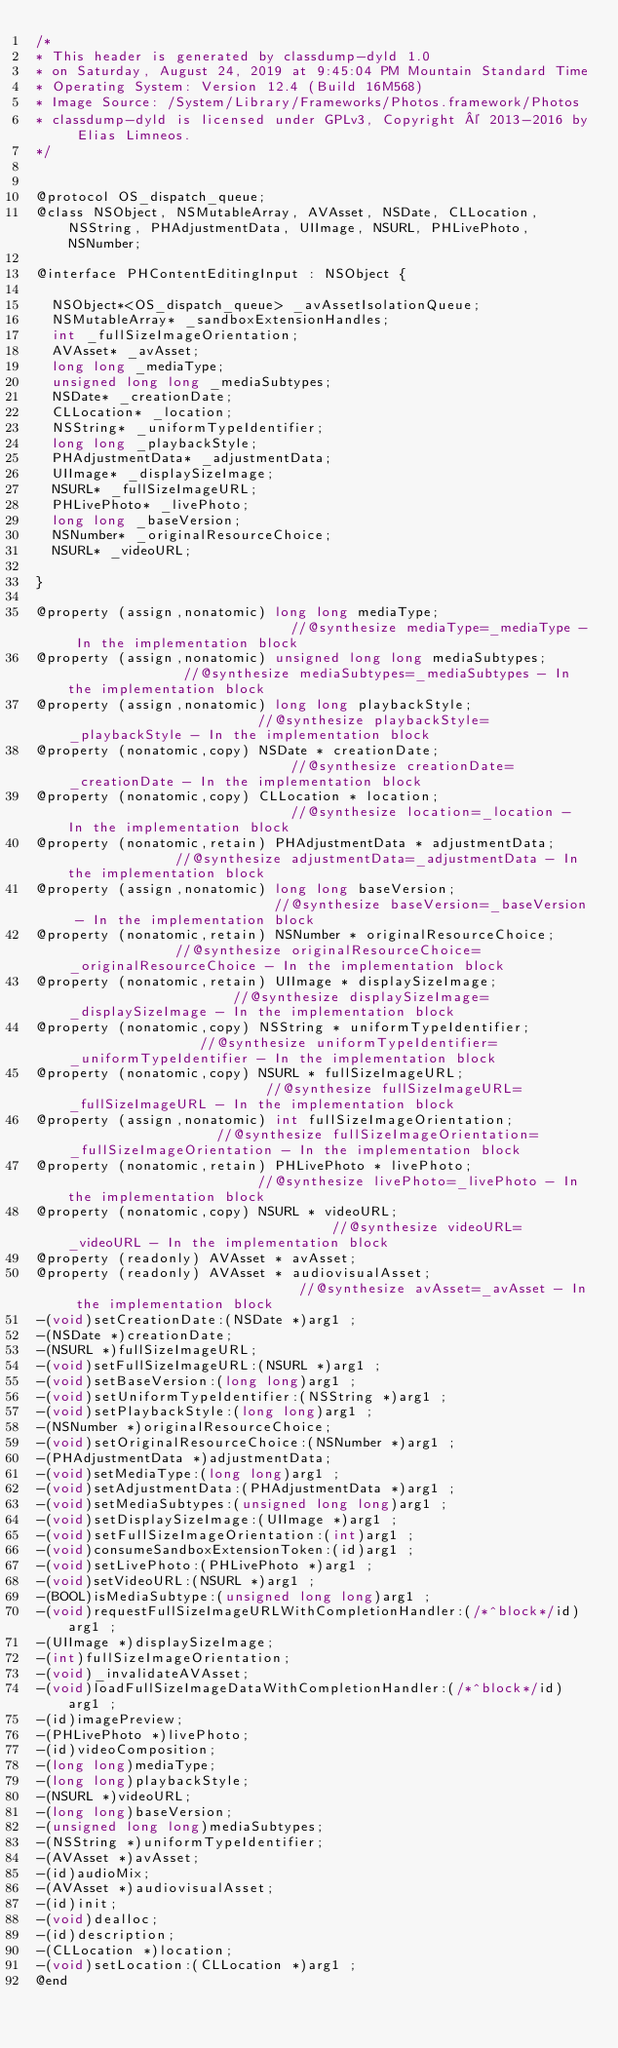Convert code to text. <code><loc_0><loc_0><loc_500><loc_500><_C_>/*
* This header is generated by classdump-dyld 1.0
* on Saturday, August 24, 2019 at 9:45:04 PM Mountain Standard Time
* Operating System: Version 12.4 (Build 16M568)
* Image Source: /System/Library/Frameworks/Photos.framework/Photos
* classdump-dyld is licensed under GPLv3, Copyright © 2013-2016 by Elias Limneos.
*/


@protocol OS_dispatch_queue;
@class NSObject, NSMutableArray, AVAsset, NSDate, CLLocation, NSString, PHAdjustmentData, UIImage, NSURL, PHLivePhoto, NSNumber;

@interface PHContentEditingInput : NSObject {

	NSObject*<OS_dispatch_queue> _avAssetIsolationQueue;
	NSMutableArray* _sandboxExtensionHandles;
	int _fullSizeImageOrientation;
	AVAsset* _avAsset;
	long long _mediaType;
	unsigned long long _mediaSubtypes;
	NSDate* _creationDate;
	CLLocation* _location;
	NSString* _uniformTypeIdentifier;
	long long _playbackStyle;
	PHAdjustmentData* _adjustmentData;
	UIImage* _displaySizeImage;
	NSURL* _fullSizeImageURL;
	PHLivePhoto* _livePhoto;
	long long _baseVersion;
	NSNumber* _originalResourceChoice;
	NSURL* _videoURL;

}

@property (assign,nonatomic) long long mediaType;                            //@synthesize mediaType=_mediaType - In the implementation block
@property (assign,nonatomic) unsigned long long mediaSubtypes;               //@synthesize mediaSubtypes=_mediaSubtypes - In the implementation block
@property (assign,nonatomic) long long playbackStyle;                        //@synthesize playbackStyle=_playbackStyle - In the implementation block
@property (nonatomic,copy) NSDate * creationDate;                            //@synthesize creationDate=_creationDate - In the implementation block
@property (nonatomic,copy) CLLocation * location;                            //@synthesize location=_location - In the implementation block
@property (nonatomic,retain) PHAdjustmentData * adjustmentData;              //@synthesize adjustmentData=_adjustmentData - In the implementation block
@property (assign,nonatomic) long long baseVersion;                          //@synthesize baseVersion=_baseVersion - In the implementation block
@property (nonatomic,retain) NSNumber * originalResourceChoice;              //@synthesize originalResourceChoice=_originalResourceChoice - In the implementation block
@property (nonatomic,retain) UIImage * displaySizeImage;                     //@synthesize displaySizeImage=_displaySizeImage - In the implementation block
@property (nonatomic,copy) NSString * uniformTypeIdentifier;                 //@synthesize uniformTypeIdentifier=_uniformTypeIdentifier - In the implementation block
@property (nonatomic,copy) NSURL * fullSizeImageURL;                         //@synthesize fullSizeImageURL=_fullSizeImageURL - In the implementation block
@property (assign,nonatomic) int fullSizeImageOrientation;                   //@synthesize fullSizeImageOrientation=_fullSizeImageOrientation - In the implementation block
@property (nonatomic,retain) PHLivePhoto * livePhoto;                        //@synthesize livePhoto=_livePhoto - In the implementation block
@property (nonatomic,copy) NSURL * videoURL;                                 //@synthesize videoURL=_videoURL - In the implementation block
@property (readonly) AVAsset * avAsset; 
@property (readonly) AVAsset * audiovisualAsset;                             //@synthesize avAsset=_avAsset - In the implementation block
-(void)setCreationDate:(NSDate *)arg1 ;
-(NSDate *)creationDate;
-(NSURL *)fullSizeImageURL;
-(void)setFullSizeImageURL:(NSURL *)arg1 ;
-(void)setBaseVersion:(long long)arg1 ;
-(void)setUniformTypeIdentifier:(NSString *)arg1 ;
-(void)setPlaybackStyle:(long long)arg1 ;
-(NSNumber *)originalResourceChoice;
-(void)setOriginalResourceChoice:(NSNumber *)arg1 ;
-(PHAdjustmentData *)adjustmentData;
-(void)setMediaType:(long long)arg1 ;
-(void)setAdjustmentData:(PHAdjustmentData *)arg1 ;
-(void)setMediaSubtypes:(unsigned long long)arg1 ;
-(void)setDisplaySizeImage:(UIImage *)arg1 ;
-(void)setFullSizeImageOrientation:(int)arg1 ;
-(void)consumeSandboxExtensionToken:(id)arg1 ;
-(void)setLivePhoto:(PHLivePhoto *)arg1 ;
-(void)setVideoURL:(NSURL *)arg1 ;
-(BOOL)isMediaSubtype:(unsigned long long)arg1 ;
-(void)requestFullSizeImageURLWithCompletionHandler:(/*^block*/id)arg1 ;
-(UIImage *)displaySizeImage;
-(int)fullSizeImageOrientation;
-(void)_invalidateAVAsset;
-(void)loadFullSizeImageDataWithCompletionHandler:(/*^block*/id)arg1 ;
-(id)imagePreview;
-(PHLivePhoto *)livePhoto;
-(id)videoComposition;
-(long long)mediaType;
-(long long)playbackStyle;
-(NSURL *)videoURL;
-(long long)baseVersion;
-(unsigned long long)mediaSubtypes;
-(NSString *)uniformTypeIdentifier;
-(AVAsset *)avAsset;
-(id)audioMix;
-(AVAsset *)audiovisualAsset;
-(id)init;
-(void)dealloc;
-(id)description;
-(CLLocation *)location;
-(void)setLocation:(CLLocation *)arg1 ;
@end

</code> 